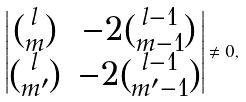Convert formula to latex. <formula><loc_0><loc_0><loc_500><loc_500>\left | \begin{matrix} { l \choose m } & - 2 { l - 1 \choose m - 1 } \\ { l \choose m ^ { \prime } } & - 2 { l - 1 \choose m ^ { \prime } - 1 } \end{matrix} \right | \ne 0 ,</formula> 